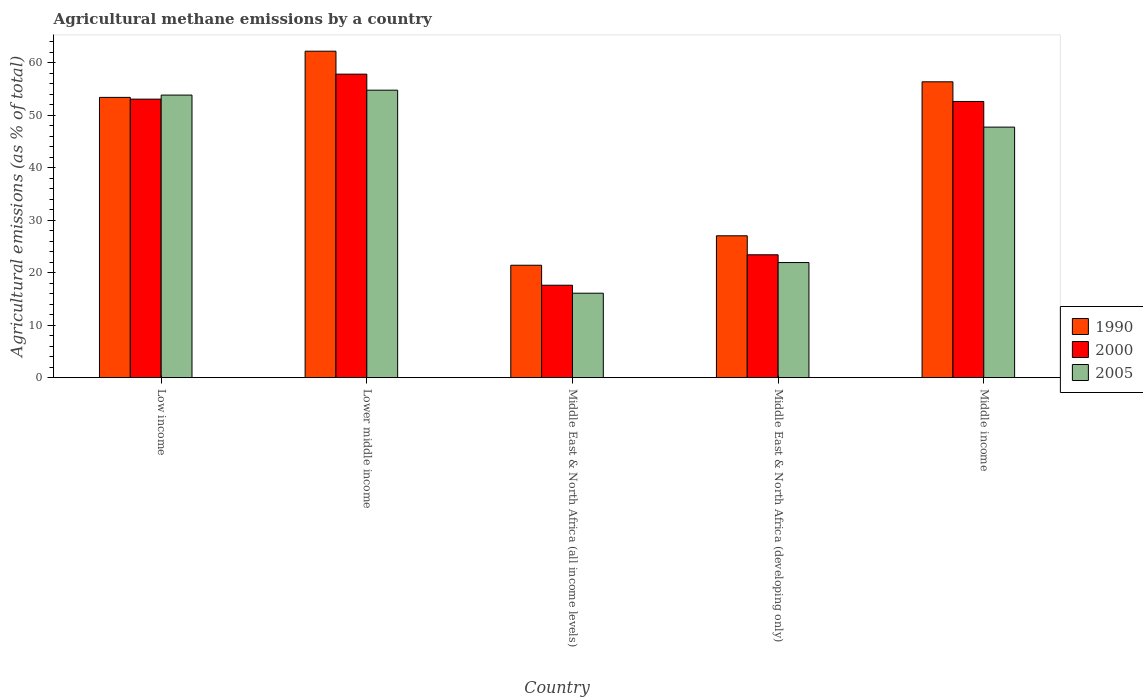How many groups of bars are there?
Offer a very short reply. 5. Are the number of bars on each tick of the X-axis equal?
Your answer should be very brief. Yes. How many bars are there on the 3rd tick from the left?
Make the answer very short. 3. What is the label of the 3rd group of bars from the left?
Give a very brief answer. Middle East & North Africa (all income levels). What is the amount of agricultural methane emitted in 2005 in Lower middle income?
Keep it short and to the point. 54.76. Across all countries, what is the maximum amount of agricultural methane emitted in 2000?
Provide a short and direct response. 57.81. Across all countries, what is the minimum amount of agricultural methane emitted in 2000?
Make the answer very short. 17.61. In which country was the amount of agricultural methane emitted in 1990 maximum?
Make the answer very short. Lower middle income. In which country was the amount of agricultural methane emitted in 2005 minimum?
Offer a very short reply. Middle East & North Africa (all income levels). What is the total amount of agricultural methane emitted in 2005 in the graph?
Provide a short and direct response. 194.32. What is the difference between the amount of agricultural methane emitted in 1990 in Low income and that in Middle East & North Africa (all income levels)?
Your response must be concise. 31.97. What is the difference between the amount of agricultural methane emitted in 2005 in Middle income and the amount of agricultural methane emitted in 1990 in Lower middle income?
Ensure brevity in your answer.  -14.46. What is the average amount of agricultural methane emitted in 2000 per country?
Your answer should be compact. 40.9. What is the difference between the amount of agricultural methane emitted of/in 2000 and amount of agricultural methane emitted of/in 1990 in Middle East & North Africa (developing only)?
Offer a terse response. -3.62. What is the ratio of the amount of agricultural methane emitted in 1990 in Middle East & North Africa (developing only) to that in Middle income?
Your answer should be compact. 0.48. Is the amount of agricultural methane emitted in 1990 in Middle East & North Africa (all income levels) less than that in Middle East & North Africa (developing only)?
Your answer should be very brief. Yes. Is the difference between the amount of agricultural methane emitted in 2000 in Lower middle income and Middle East & North Africa (all income levels) greater than the difference between the amount of agricultural methane emitted in 1990 in Lower middle income and Middle East & North Africa (all income levels)?
Your answer should be compact. No. What is the difference between the highest and the second highest amount of agricultural methane emitted in 2005?
Keep it short and to the point. -0.94. What is the difference between the highest and the lowest amount of agricultural methane emitted in 1990?
Make the answer very short. 40.77. Is the sum of the amount of agricultural methane emitted in 1990 in Low income and Middle income greater than the maximum amount of agricultural methane emitted in 2000 across all countries?
Offer a terse response. Yes. How many bars are there?
Your answer should be very brief. 15. Are all the bars in the graph horizontal?
Ensure brevity in your answer.  No. How many countries are there in the graph?
Give a very brief answer. 5. What is the difference between two consecutive major ticks on the Y-axis?
Ensure brevity in your answer.  10. How many legend labels are there?
Your answer should be very brief. 3. What is the title of the graph?
Give a very brief answer. Agricultural methane emissions by a country. What is the label or title of the Y-axis?
Keep it short and to the point. Agricultural emissions (as % of total). What is the Agricultural emissions (as % of total) in 1990 in Low income?
Your answer should be very brief. 53.39. What is the Agricultural emissions (as % of total) of 2000 in Low income?
Offer a terse response. 53.05. What is the Agricultural emissions (as % of total) in 2005 in Low income?
Provide a succinct answer. 53.82. What is the Agricultural emissions (as % of total) in 1990 in Lower middle income?
Offer a terse response. 62.18. What is the Agricultural emissions (as % of total) of 2000 in Lower middle income?
Make the answer very short. 57.81. What is the Agricultural emissions (as % of total) in 2005 in Lower middle income?
Provide a short and direct response. 54.76. What is the Agricultural emissions (as % of total) in 1990 in Middle East & North Africa (all income levels)?
Make the answer very short. 21.41. What is the Agricultural emissions (as % of total) of 2000 in Middle East & North Africa (all income levels)?
Provide a short and direct response. 17.61. What is the Agricultural emissions (as % of total) in 2005 in Middle East & North Africa (all income levels)?
Keep it short and to the point. 16.09. What is the Agricultural emissions (as % of total) of 1990 in Middle East & North Africa (developing only)?
Offer a very short reply. 27.03. What is the Agricultural emissions (as % of total) in 2000 in Middle East & North Africa (developing only)?
Provide a succinct answer. 23.4. What is the Agricultural emissions (as % of total) of 2005 in Middle East & North Africa (developing only)?
Your response must be concise. 21.93. What is the Agricultural emissions (as % of total) in 1990 in Middle income?
Offer a terse response. 56.35. What is the Agricultural emissions (as % of total) of 2000 in Middle income?
Provide a succinct answer. 52.61. What is the Agricultural emissions (as % of total) in 2005 in Middle income?
Your answer should be compact. 47.72. Across all countries, what is the maximum Agricultural emissions (as % of total) in 1990?
Offer a terse response. 62.18. Across all countries, what is the maximum Agricultural emissions (as % of total) of 2000?
Provide a short and direct response. 57.81. Across all countries, what is the maximum Agricultural emissions (as % of total) of 2005?
Offer a very short reply. 54.76. Across all countries, what is the minimum Agricultural emissions (as % of total) of 1990?
Ensure brevity in your answer.  21.41. Across all countries, what is the minimum Agricultural emissions (as % of total) in 2000?
Make the answer very short. 17.61. Across all countries, what is the minimum Agricultural emissions (as % of total) of 2005?
Offer a terse response. 16.09. What is the total Agricultural emissions (as % of total) of 1990 in the graph?
Offer a very short reply. 220.37. What is the total Agricultural emissions (as % of total) of 2000 in the graph?
Ensure brevity in your answer.  204.49. What is the total Agricultural emissions (as % of total) of 2005 in the graph?
Your answer should be very brief. 194.32. What is the difference between the Agricultural emissions (as % of total) of 1990 in Low income and that in Lower middle income?
Provide a succinct answer. -8.8. What is the difference between the Agricultural emissions (as % of total) of 2000 in Low income and that in Lower middle income?
Offer a terse response. -4.76. What is the difference between the Agricultural emissions (as % of total) in 2005 in Low income and that in Lower middle income?
Ensure brevity in your answer.  -0.94. What is the difference between the Agricultural emissions (as % of total) of 1990 in Low income and that in Middle East & North Africa (all income levels)?
Ensure brevity in your answer.  31.97. What is the difference between the Agricultural emissions (as % of total) of 2000 in Low income and that in Middle East & North Africa (all income levels)?
Your response must be concise. 35.45. What is the difference between the Agricultural emissions (as % of total) in 2005 in Low income and that in Middle East & North Africa (all income levels)?
Your response must be concise. 37.74. What is the difference between the Agricultural emissions (as % of total) in 1990 in Low income and that in Middle East & North Africa (developing only)?
Your answer should be compact. 26.36. What is the difference between the Agricultural emissions (as % of total) in 2000 in Low income and that in Middle East & North Africa (developing only)?
Provide a short and direct response. 29.65. What is the difference between the Agricultural emissions (as % of total) in 2005 in Low income and that in Middle East & North Africa (developing only)?
Your response must be concise. 31.9. What is the difference between the Agricultural emissions (as % of total) of 1990 in Low income and that in Middle income?
Give a very brief answer. -2.97. What is the difference between the Agricultural emissions (as % of total) of 2000 in Low income and that in Middle income?
Offer a terse response. 0.44. What is the difference between the Agricultural emissions (as % of total) of 2005 in Low income and that in Middle income?
Ensure brevity in your answer.  6.1. What is the difference between the Agricultural emissions (as % of total) in 1990 in Lower middle income and that in Middle East & North Africa (all income levels)?
Ensure brevity in your answer.  40.77. What is the difference between the Agricultural emissions (as % of total) in 2000 in Lower middle income and that in Middle East & North Africa (all income levels)?
Offer a very short reply. 40.2. What is the difference between the Agricultural emissions (as % of total) in 2005 in Lower middle income and that in Middle East & North Africa (all income levels)?
Provide a succinct answer. 38.67. What is the difference between the Agricultural emissions (as % of total) in 1990 in Lower middle income and that in Middle East & North Africa (developing only)?
Keep it short and to the point. 35.16. What is the difference between the Agricultural emissions (as % of total) in 2000 in Lower middle income and that in Middle East & North Africa (developing only)?
Provide a short and direct response. 34.41. What is the difference between the Agricultural emissions (as % of total) in 2005 in Lower middle income and that in Middle East & North Africa (developing only)?
Make the answer very short. 32.83. What is the difference between the Agricultural emissions (as % of total) of 1990 in Lower middle income and that in Middle income?
Your response must be concise. 5.83. What is the difference between the Agricultural emissions (as % of total) in 2000 in Lower middle income and that in Middle income?
Give a very brief answer. 5.2. What is the difference between the Agricultural emissions (as % of total) of 2005 in Lower middle income and that in Middle income?
Provide a short and direct response. 7.04. What is the difference between the Agricultural emissions (as % of total) of 1990 in Middle East & North Africa (all income levels) and that in Middle East & North Africa (developing only)?
Your answer should be very brief. -5.61. What is the difference between the Agricultural emissions (as % of total) in 2000 in Middle East & North Africa (all income levels) and that in Middle East & North Africa (developing only)?
Your answer should be very brief. -5.8. What is the difference between the Agricultural emissions (as % of total) of 2005 in Middle East & North Africa (all income levels) and that in Middle East & North Africa (developing only)?
Your answer should be compact. -5.84. What is the difference between the Agricultural emissions (as % of total) of 1990 in Middle East & North Africa (all income levels) and that in Middle income?
Your answer should be very brief. -34.94. What is the difference between the Agricultural emissions (as % of total) in 2000 in Middle East & North Africa (all income levels) and that in Middle income?
Provide a short and direct response. -35. What is the difference between the Agricultural emissions (as % of total) in 2005 in Middle East & North Africa (all income levels) and that in Middle income?
Make the answer very short. -31.64. What is the difference between the Agricultural emissions (as % of total) of 1990 in Middle East & North Africa (developing only) and that in Middle income?
Ensure brevity in your answer.  -29.33. What is the difference between the Agricultural emissions (as % of total) of 2000 in Middle East & North Africa (developing only) and that in Middle income?
Ensure brevity in your answer.  -29.21. What is the difference between the Agricultural emissions (as % of total) in 2005 in Middle East & North Africa (developing only) and that in Middle income?
Provide a succinct answer. -25.8. What is the difference between the Agricultural emissions (as % of total) of 1990 in Low income and the Agricultural emissions (as % of total) of 2000 in Lower middle income?
Offer a very short reply. -4.42. What is the difference between the Agricultural emissions (as % of total) of 1990 in Low income and the Agricultural emissions (as % of total) of 2005 in Lower middle income?
Your response must be concise. -1.37. What is the difference between the Agricultural emissions (as % of total) in 2000 in Low income and the Agricultural emissions (as % of total) in 2005 in Lower middle income?
Provide a succinct answer. -1.7. What is the difference between the Agricultural emissions (as % of total) in 1990 in Low income and the Agricultural emissions (as % of total) in 2000 in Middle East & North Africa (all income levels)?
Keep it short and to the point. 35.78. What is the difference between the Agricultural emissions (as % of total) of 1990 in Low income and the Agricultural emissions (as % of total) of 2005 in Middle East & North Africa (all income levels)?
Ensure brevity in your answer.  37.3. What is the difference between the Agricultural emissions (as % of total) in 2000 in Low income and the Agricultural emissions (as % of total) in 2005 in Middle East & North Africa (all income levels)?
Provide a succinct answer. 36.97. What is the difference between the Agricultural emissions (as % of total) in 1990 in Low income and the Agricultural emissions (as % of total) in 2000 in Middle East & North Africa (developing only)?
Provide a succinct answer. 29.98. What is the difference between the Agricultural emissions (as % of total) in 1990 in Low income and the Agricultural emissions (as % of total) in 2005 in Middle East & North Africa (developing only)?
Offer a terse response. 31.46. What is the difference between the Agricultural emissions (as % of total) in 2000 in Low income and the Agricultural emissions (as % of total) in 2005 in Middle East & North Africa (developing only)?
Provide a short and direct response. 31.13. What is the difference between the Agricultural emissions (as % of total) of 1990 in Low income and the Agricultural emissions (as % of total) of 2000 in Middle income?
Keep it short and to the point. 0.78. What is the difference between the Agricultural emissions (as % of total) of 1990 in Low income and the Agricultural emissions (as % of total) of 2005 in Middle income?
Provide a succinct answer. 5.66. What is the difference between the Agricultural emissions (as % of total) in 2000 in Low income and the Agricultural emissions (as % of total) in 2005 in Middle income?
Your response must be concise. 5.33. What is the difference between the Agricultural emissions (as % of total) in 1990 in Lower middle income and the Agricultural emissions (as % of total) in 2000 in Middle East & North Africa (all income levels)?
Give a very brief answer. 44.58. What is the difference between the Agricultural emissions (as % of total) in 1990 in Lower middle income and the Agricultural emissions (as % of total) in 2005 in Middle East & North Africa (all income levels)?
Give a very brief answer. 46.1. What is the difference between the Agricultural emissions (as % of total) in 2000 in Lower middle income and the Agricultural emissions (as % of total) in 2005 in Middle East & North Africa (all income levels)?
Provide a succinct answer. 41.73. What is the difference between the Agricultural emissions (as % of total) of 1990 in Lower middle income and the Agricultural emissions (as % of total) of 2000 in Middle East & North Africa (developing only)?
Provide a short and direct response. 38.78. What is the difference between the Agricultural emissions (as % of total) of 1990 in Lower middle income and the Agricultural emissions (as % of total) of 2005 in Middle East & North Africa (developing only)?
Your answer should be very brief. 40.26. What is the difference between the Agricultural emissions (as % of total) in 2000 in Lower middle income and the Agricultural emissions (as % of total) in 2005 in Middle East & North Africa (developing only)?
Your answer should be very brief. 35.89. What is the difference between the Agricultural emissions (as % of total) of 1990 in Lower middle income and the Agricultural emissions (as % of total) of 2000 in Middle income?
Your response must be concise. 9.57. What is the difference between the Agricultural emissions (as % of total) of 1990 in Lower middle income and the Agricultural emissions (as % of total) of 2005 in Middle income?
Offer a very short reply. 14.46. What is the difference between the Agricultural emissions (as % of total) of 2000 in Lower middle income and the Agricultural emissions (as % of total) of 2005 in Middle income?
Give a very brief answer. 10.09. What is the difference between the Agricultural emissions (as % of total) in 1990 in Middle East & North Africa (all income levels) and the Agricultural emissions (as % of total) in 2000 in Middle East & North Africa (developing only)?
Your answer should be compact. -1.99. What is the difference between the Agricultural emissions (as % of total) in 1990 in Middle East & North Africa (all income levels) and the Agricultural emissions (as % of total) in 2005 in Middle East & North Africa (developing only)?
Provide a succinct answer. -0.51. What is the difference between the Agricultural emissions (as % of total) in 2000 in Middle East & North Africa (all income levels) and the Agricultural emissions (as % of total) in 2005 in Middle East & North Africa (developing only)?
Give a very brief answer. -4.32. What is the difference between the Agricultural emissions (as % of total) of 1990 in Middle East & North Africa (all income levels) and the Agricultural emissions (as % of total) of 2000 in Middle income?
Provide a short and direct response. -31.2. What is the difference between the Agricultural emissions (as % of total) of 1990 in Middle East & North Africa (all income levels) and the Agricultural emissions (as % of total) of 2005 in Middle income?
Your response must be concise. -26.31. What is the difference between the Agricultural emissions (as % of total) of 2000 in Middle East & North Africa (all income levels) and the Agricultural emissions (as % of total) of 2005 in Middle income?
Provide a short and direct response. -30.12. What is the difference between the Agricultural emissions (as % of total) of 1990 in Middle East & North Africa (developing only) and the Agricultural emissions (as % of total) of 2000 in Middle income?
Ensure brevity in your answer.  -25.58. What is the difference between the Agricultural emissions (as % of total) in 1990 in Middle East & North Africa (developing only) and the Agricultural emissions (as % of total) in 2005 in Middle income?
Offer a very short reply. -20.7. What is the difference between the Agricultural emissions (as % of total) in 2000 in Middle East & North Africa (developing only) and the Agricultural emissions (as % of total) in 2005 in Middle income?
Make the answer very short. -24.32. What is the average Agricultural emissions (as % of total) in 1990 per country?
Offer a very short reply. 44.07. What is the average Agricultural emissions (as % of total) in 2000 per country?
Offer a terse response. 40.9. What is the average Agricultural emissions (as % of total) in 2005 per country?
Your response must be concise. 38.86. What is the difference between the Agricultural emissions (as % of total) of 1990 and Agricultural emissions (as % of total) of 2000 in Low income?
Offer a very short reply. 0.33. What is the difference between the Agricultural emissions (as % of total) in 1990 and Agricultural emissions (as % of total) in 2005 in Low income?
Make the answer very short. -0.44. What is the difference between the Agricultural emissions (as % of total) of 2000 and Agricultural emissions (as % of total) of 2005 in Low income?
Your answer should be compact. -0.77. What is the difference between the Agricultural emissions (as % of total) in 1990 and Agricultural emissions (as % of total) in 2000 in Lower middle income?
Your response must be concise. 4.37. What is the difference between the Agricultural emissions (as % of total) of 1990 and Agricultural emissions (as % of total) of 2005 in Lower middle income?
Give a very brief answer. 7.42. What is the difference between the Agricultural emissions (as % of total) of 2000 and Agricultural emissions (as % of total) of 2005 in Lower middle income?
Your answer should be very brief. 3.05. What is the difference between the Agricultural emissions (as % of total) in 1990 and Agricultural emissions (as % of total) in 2000 in Middle East & North Africa (all income levels)?
Your response must be concise. 3.81. What is the difference between the Agricultural emissions (as % of total) in 1990 and Agricultural emissions (as % of total) in 2005 in Middle East & North Africa (all income levels)?
Your answer should be compact. 5.33. What is the difference between the Agricultural emissions (as % of total) in 2000 and Agricultural emissions (as % of total) in 2005 in Middle East & North Africa (all income levels)?
Offer a very short reply. 1.52. What is the difference between the Agricultural emissions (as % of total) in 1990 and Agricultural emissions (as % of total) in 2000 in Middle East & North Africa (developing only)?
Your answer should be compact. 3.62. What is the difference between the Agricultural emissions (as % of total) in 1990 and Agricultural emissions (as % of total) in 2005 in Middle East & North Africa (developing only)?
Your response must be concise. 5.1. What is the difference between the Agricultural emissions (as % of total) in 2000 and Agricultural emissions (as % of total) in 2005 in Middle East & North Africa (developing only)?
Give a very brief answer. 1.48. What is the difference between the Agricultural emissions (as % of total) of 1990 and Agricultural emissions (as % of total) of 2000 in Middle income?
Give a very brief answer. 3.74. What is the difference between the Agricultural emissions (as % of total) in 1990 and Agricultural emissions (as % of total) in 2005 in Middle income?
Provide a short and direct response. 8.63. What is the difference between the Agricultural emissions (as % of total) in 2000 and Agricultural emissions (as % of total) in 2005 in Middle income?
Your answer should be very brief. 4.89. What is the ratio of the Agricultural emissions (as % of total) in 1990 in Low income to that in Lower middle income?
Your answer should be very brief. 0.86. What is the ratio of the Agricultural emissions (as % of total) of 2000 in Low income to that in Lower middle income?
Provide a succinct answer. 0.92. What is the ratio of the Agricultural emissions (as % of total) in 2005 in Low income to that in Lower middle income?
Provide a short and direct response. 0.98. What is the ratio of the Agricultural emissions (as % of total) of 1990 in Low income to that in Middle East & North Africa (all income levels)?
Give a very brief answer. 2.49. What is the ratio of the Agricultural emissions (as % of total) of 2000 in Low income to that in Middle East & North Africa (all income levels)?
Make the answer very short. 3.01. What is the ratio of the Agricultural emissions (as % of total) in 2005 in Low income to that in Middle East & North Africa (all income levels)?
Your response must be concise. 3.35. What is the ratio of the Agricultural emissions (as % of total) in 1990 in Low income to that in Middle East & North Africa (developing only)?
Your answer should be very brief. 1.98. What is the ratio of the Agricultural emissions (as % of total) in 2000 in Low income to that in Middle East & North Africa (developing only)?
Make the answer very short. 2.27. What is the ratio of the Agricultural emissions (as % of total) of 2005 in Low income to that in Middle East & North Africa (developing only)?
Offer a very short reply. 2.45. What is the ratio of the Agricultural emissions (as % of total) in 1990 in Low income to that in Middle income?
Keep it short and to the point. 0.95. What is the ratio of the Agricultural emissions (as % of total) in 2000 in Low income to that in Middle income?
Provide a short and direct response. 1.01. What is the ratio of the Agricultural emissions (as % of total) in 2005 in Low income to that in Middle income?
Your answer should be compact. 1.13. What is the ratio of the Agricultural emissions (as % of total) in 1990 in Lower middle income to that in Middle East & North Africa (all income levels)?
Offer a very short reply. 2.9. What is the ratio of the Agricultural emissions (as % of total) of 2000 in Lower middle income to that in Middle East & North Africa (all income levels)?
Give a very brief answer. 3.28. What is the ratio of the Agricultural emissions (as % of total) in 2005 in Lower middle income to that in Middle East & North Africa (all income levels)?
Provide a succinct answer. 3.4. What is the ratio of the Agricultural emissions (as % of total) of 1990 in Lower middle income to that in Middle East & North Africa (developing only)?
Your answer should be compact. 2.3. What is the ratio of the Agricultural emissions (as % of total) in 2000 in Lower middle income to that in Middle East & North Africa (developing only)?
Your answer should be very brief. 2.47. What is the ratio of the Agricultural emissions (as % of total) of 2005 in Lower middle income to that in Middle East & North Africa (developing only)?
Your answer should be very brief. 2.5. What is the ratio of the Agricultural emissions (as % of total) of 1990 in Lower middle income to that in Middle income?
Your answer should be compact. 1.1. What is the ratio of the Agricultural emissions (as % of total) of 2000 in Lower middle income to that in Middle income?
Offer a very short reply. 1.1. What is the ratio of the Agricultural emissions (as % of total) of 2005 in Lower middle income to that in Middle income?
Your answer should be compact. 1.15. What is the ratio of the Agricultural emissions (as % of total) in 1990 in Middle East & North Africa (all income levels) to that in Middle East & North Africa (developing only)?
Make the answer very short. 0.79. What is the ratio of the Agricultural emissions (as % of total) of 2000 in Middle East & North Africa (all income levels) to that in Middle East & North Africa (developing only)?
Keep it short and to the point. 0.75. What is the ratio of the Agricultural emissions (as % of total) in 2005 in Middle East & North Africa (all income levels) to that in Middle East & North Africa (developing only)?
Your answer should be compact. 0.73. What is the ratio of the Agricultural emissions (as % of total) of 1990 in Middle East & North Africa (all income levels) to that in Middle income?
Make the answer very short. 0.38. What is the ratio of the Agricultural emissions (as % of total) in 2000 in Middle East & North Africa (all income levels) to that in Middle income?
Give a very brief answer. 0.33. What is the ratio of the Agricultural emissions (as % of total) in 2005 in Middle East & North Africa (all income levels) to that in Middle income?
Make the answer very short. 0.34. What is the ratio of the Agricultural emissions (as % of total) in 1990 in Middle East & North Africa (developing only) to that in Middle income?
Ensure brevity in your answer.  0.48. What is the ratio of the Agricultural emissions (as % of total) in 2000 in Middle East & North Africa (developing only) to that in Middle income?
Your answer should be compact. 0.44. What is the ratio of the Agricultural emissions (as % of total) in 2005 in Middle East & North Africa (developing only) to that in Middle income?
Keep it short and to the point. 0.46. What is the difference between the highest and the second highest Agricultural emissions (as % of total) in 1990?
Ensure brevity in your answer.  5.83. What is the difference between the highest and the second highest Agricultural emissions (as % of total) in 2000?
Give a very brief answer. 4.76. What is the difference between the highest and the second highest Agricultural emissions (as % of total) in 2005?
Give a very brief answer. 0.94. What is the difference between the highest and the lowest Agricultural emissions (as % of total) in 1990?
Your answer should be very brief. 40.77. What is the difference between the highest and the lowest Agricultural emissions (as % of total) of 2000?
Keep it short and to the point. 40.2. What is the difference between the highest and the lowest Agricultural emissions (as % of total) of 2005?
Give a very brief answer. 38.67. 